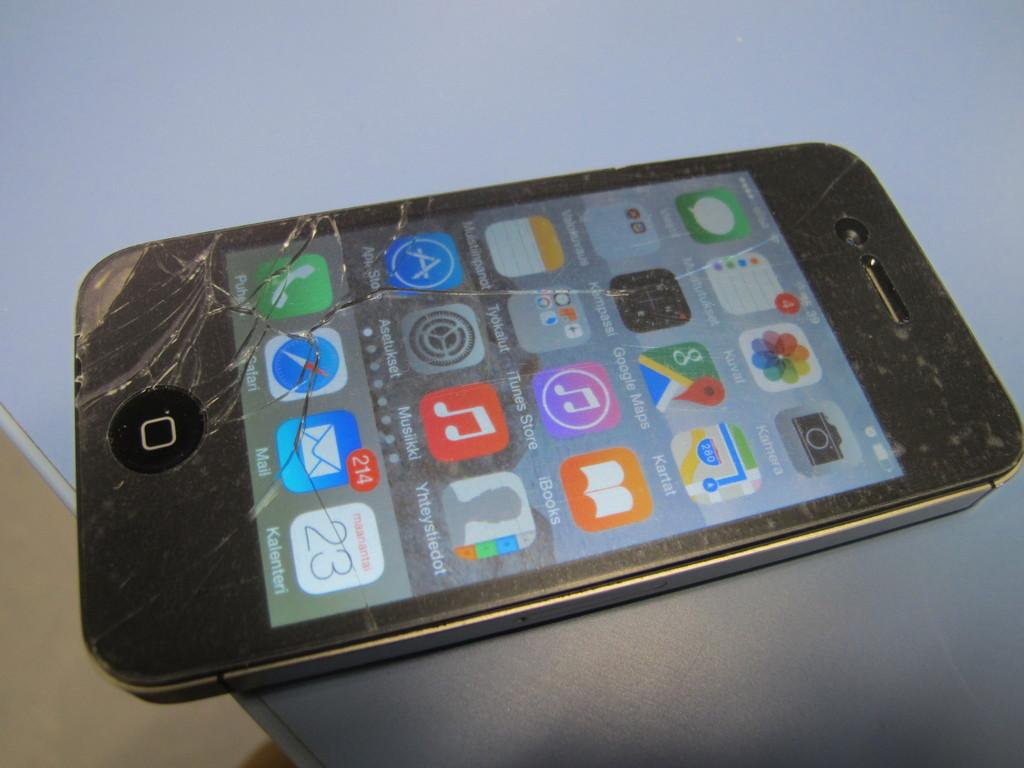Provide a one-sentence caption for the provided image. An iphone with a cracked display showing 214 unread emails. 